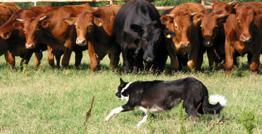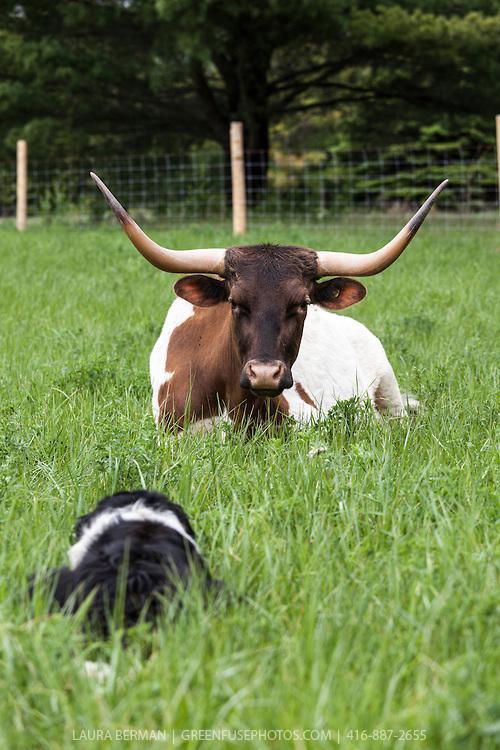The first image is the image on the left, the second image is the image on the right. Examine the images to the left and right. Is the description "The dog in the left image is facing towards the left." accurate? Answer yes or no. Yes. 